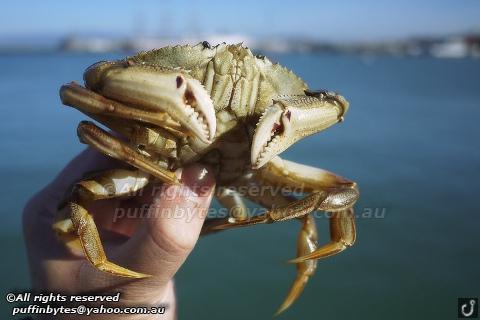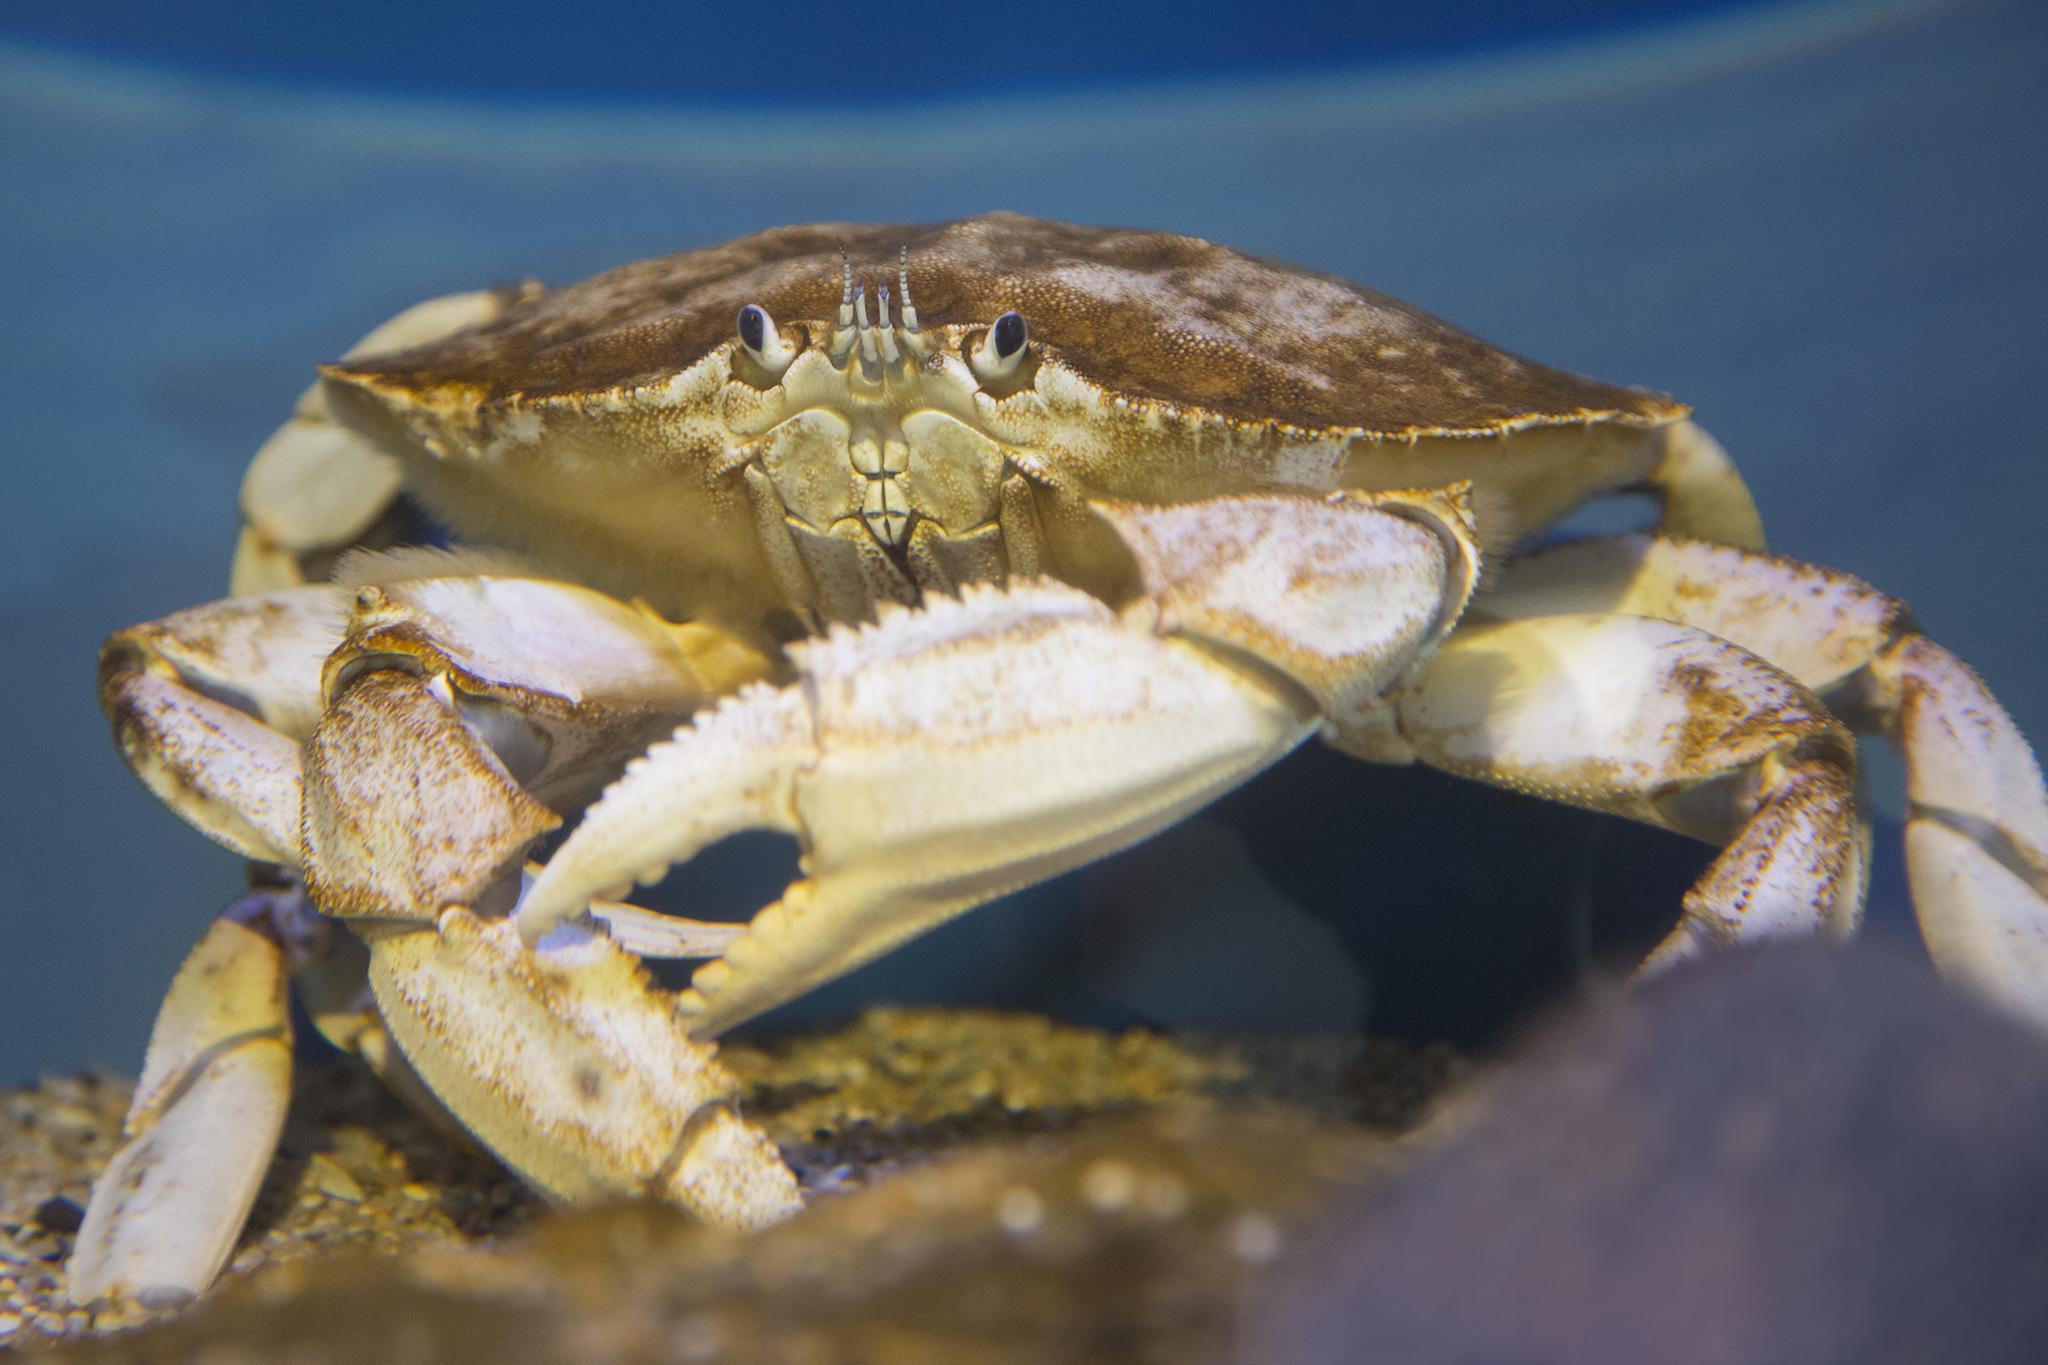The first image is the image on the left, the second image is the image on the right. For the images displayed, is the sentence "An image shows one bare hand with the thumb on the right holding up a belly-first, head-up crab, with water in the background." factually correct? Answer yes or no. Yes. The first image is the image on the left, the second image is the image on the right. For the images displayed, is the sentence "A crab is being held vertically." factually correct? Answer yes or no. Yes. 